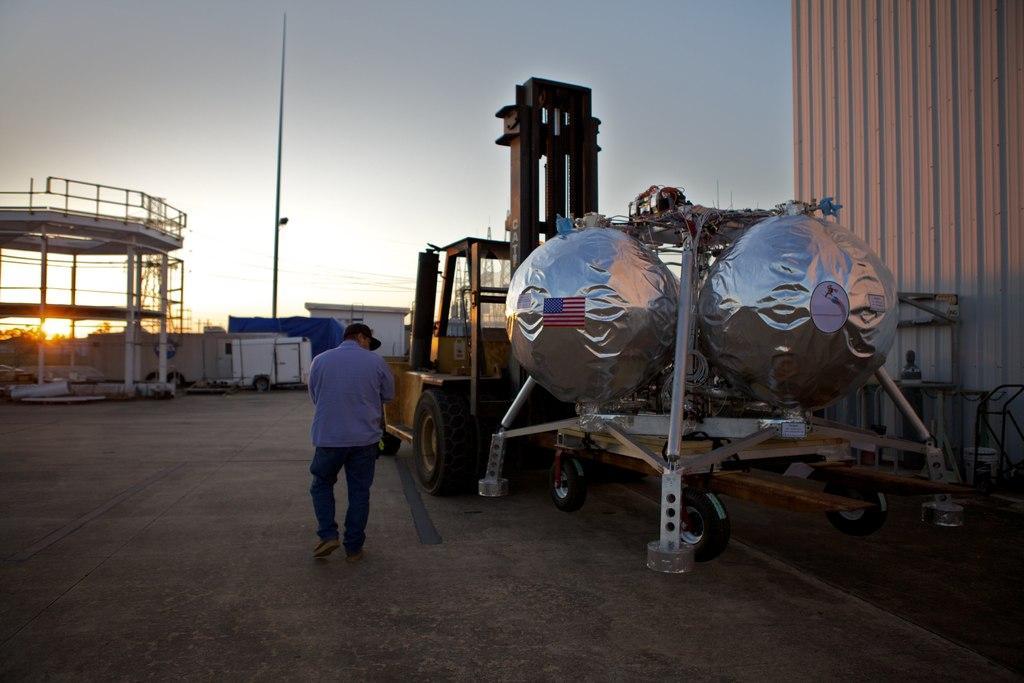Could you give a brief overview of what you see in this image? In this picture I can observe two spheres which are in silver color on the right side. There is a person walking on the road. I can observe a pole. In the background there is a sky. On the left side I can observe a sun in the sky. 